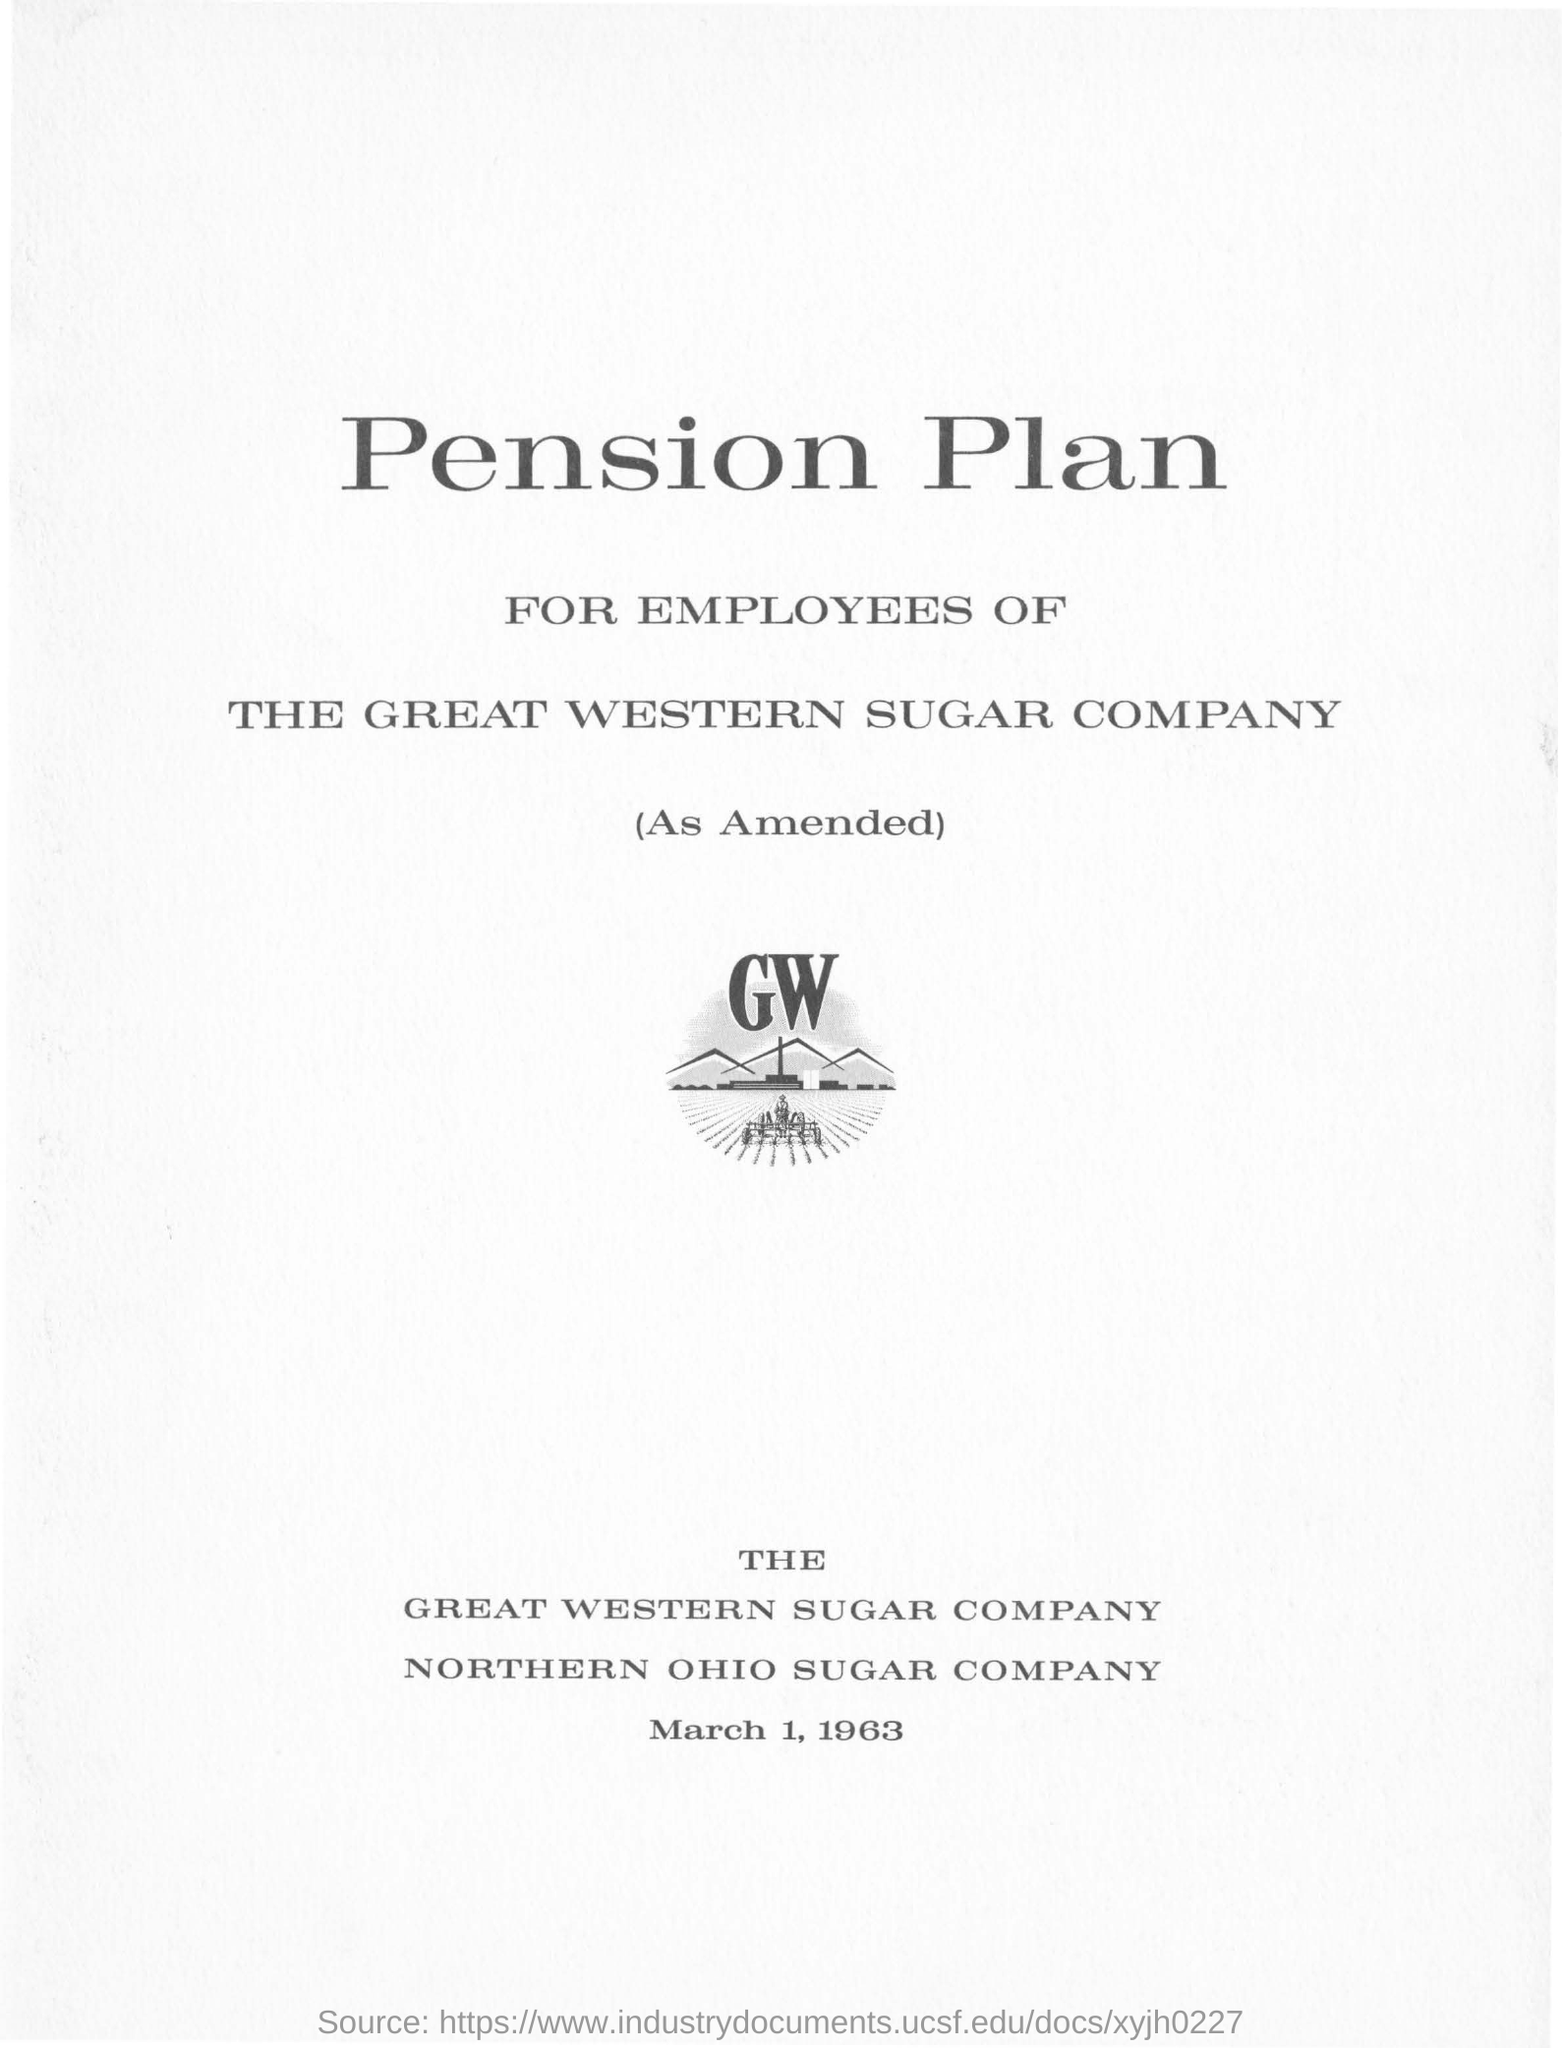What is the date on the document?
Offer a very short reply. March 1, 1963. The pension plan is for the employees of which company?
Keep it short and to the point. The Great Western Sugar Company. 